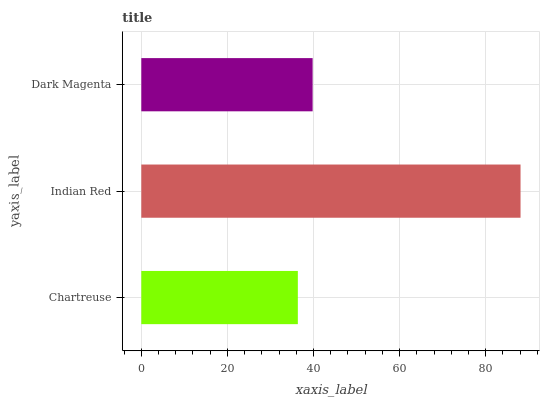Is Chartreuse the minimum?
Answer yes or no. Yes. Is Indian Red the maximum?
Answer yes or no. Yes. Is Dark Magenta the minimum?
Answer yes or no. No. Is Dark Magenta the maximum?
Answer yes or no. No. Is Indian Red greater than Dark Magenta?
Answer yes or no. Yes. Is Dark Magenta less than Indian Red?
Answer yes or no. Yes. Is Dark Magenta greater than Indian Red?
Answer yes or no. No. Is Indian Red less than Dark Magenta?
Answer yes or no. No. Is Dark Magenta the high median?
Answer yes or no. Yes. Is Dark Magenta the low median?
Answer yes or no. Yes. Is Indian Red the high median?
Answer yes or no. No. Is Chartreuse the low median?
Answer yes or no. No. 